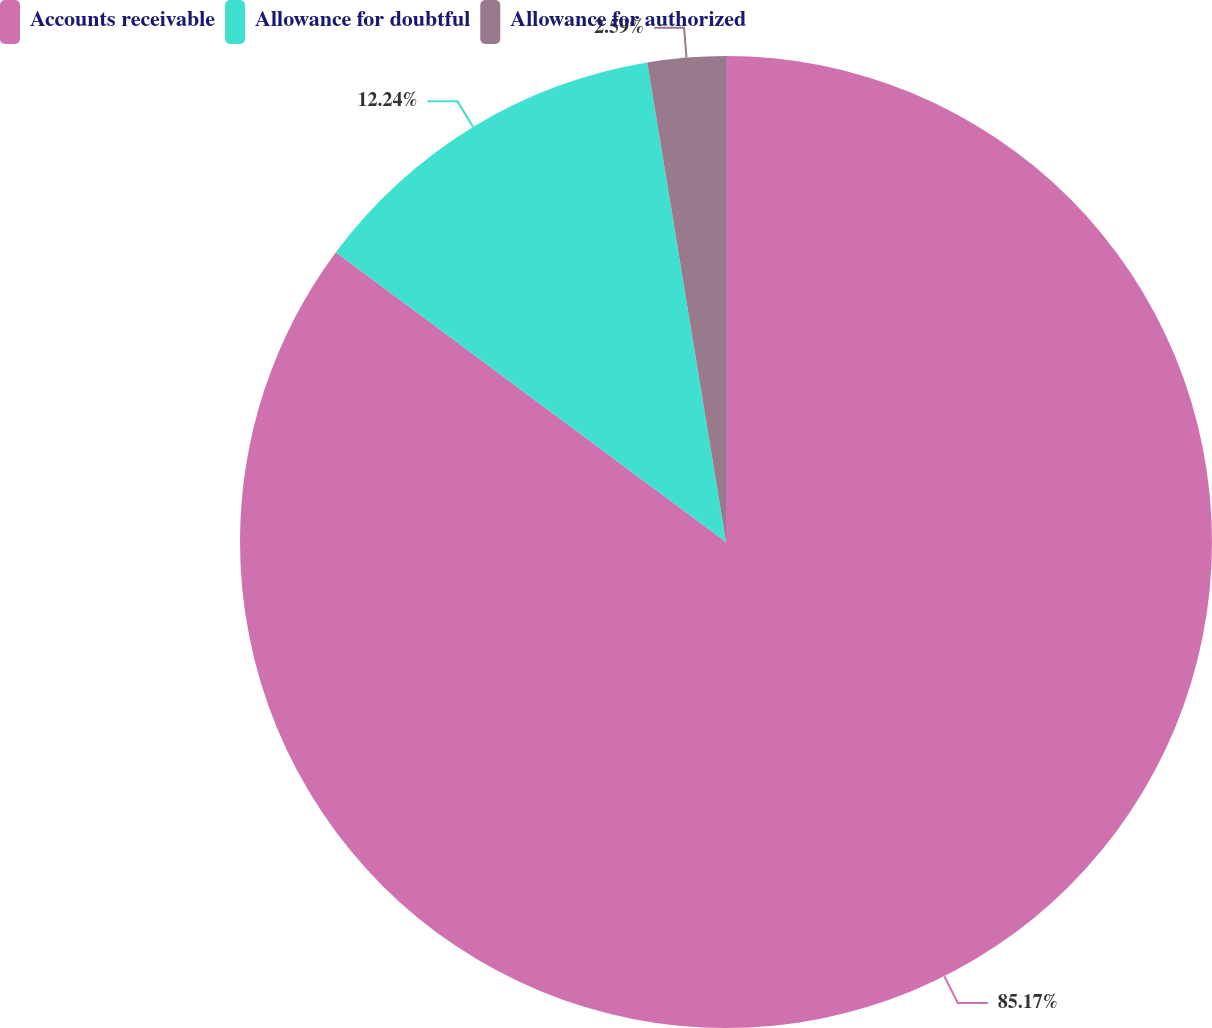Convert chart to OTSL. <chart><loc_0><loc_0><loc_500><loc_500><pie_chart><fcel>Accounts receivable<fcel>Allowance for doubtful<fcel>Allowance for authorized<nl><fcel>85.17%<fcel>12.24%<fcel>2.59%<nl></chart> 